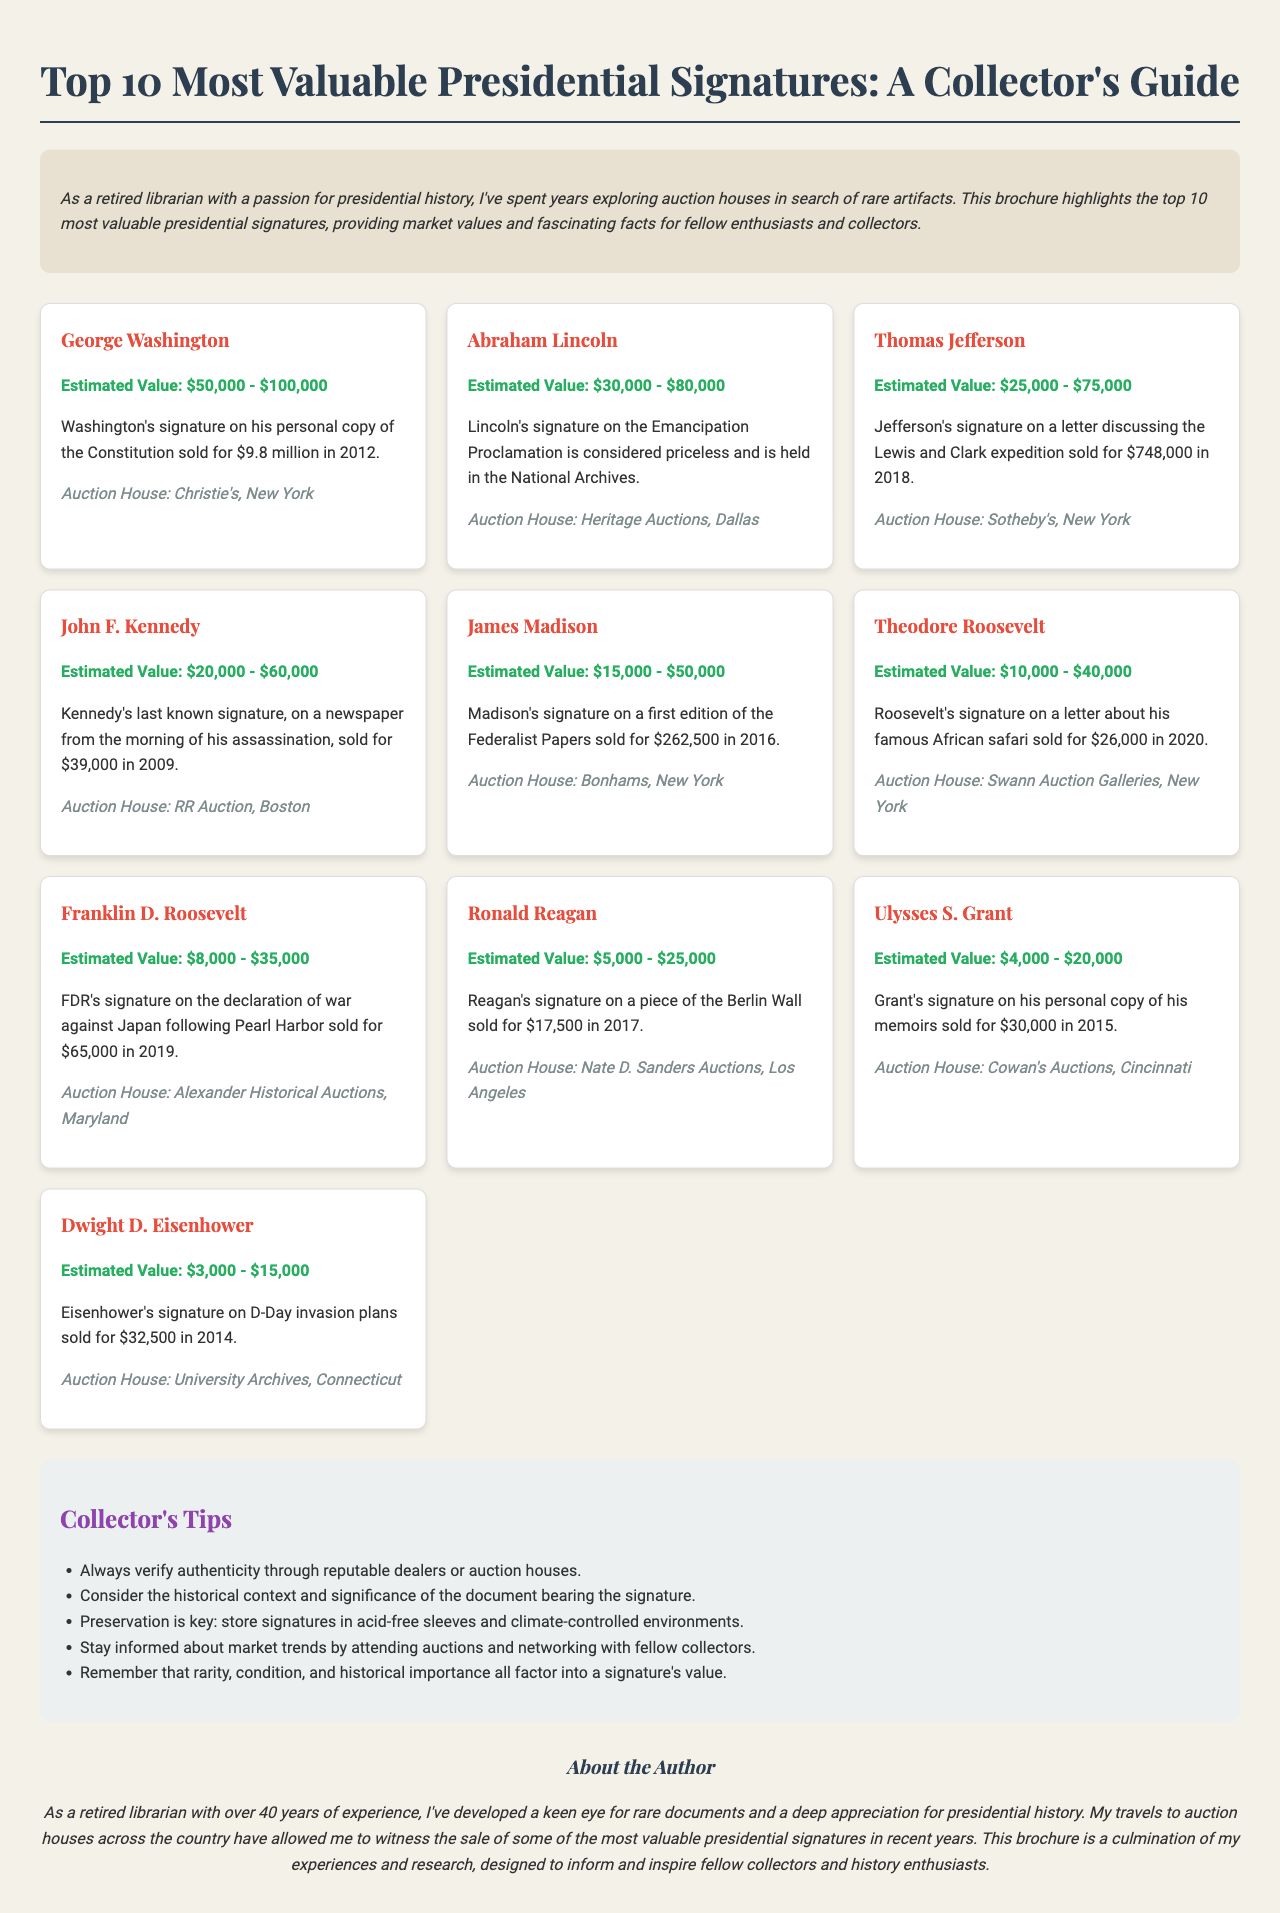What is the title of the brochure? The title is clearly stated at the top of the document, summarizing its content.
Answer: Top 10 Most Valuable Presidential Signatures: A Collector's Guide Who is the author of the document? The author is mentioned in the about section at the end of the document, providing their background.
Answer: A retired librarian What is the estimated value of George Washington's signature? It is specified in the details of Washington's entry within the signatures section.
Answer: $50,000 - $100,000 What auction house sold Thomas Jefferson's signature on a letter? The specific auction house is listed alongside Jefferson's signature details.
Answer: Sotheby's, New York Which signature had the highest recorded sale price and what was it? The document provides the sale price of Washington's signature, which is the highest.
Answer: $9.8 million What is one collector's tip mentioned in the brochure? A list of tips is included; each tip can be found in a designated tips section.
Answer: Always verify authenticity through reputable dealers or auction houses Which president's last known signature is discussed? The detail about Kennedy’s last known signature is provided in his section.
Answer: John F. Kennedy How many signatures are listed in the brochure? The total number of signatures is mentioned in the introduction and can be counted from the signatures section.
Answer: 10 What historical document is Lincoln's signature associated with? A specific document is referenced in conjunction with Lincoln's signature value.
Answer: Emancipation Proclamation 